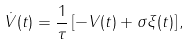<formula> <loc_0><loc_0><loc_500><loc_500>\dot { V } ( t ) = \frac { 1 } { \tau } \left [ - V ( t ) + \sigma \xi ( t ) \right ] ,</formula> 